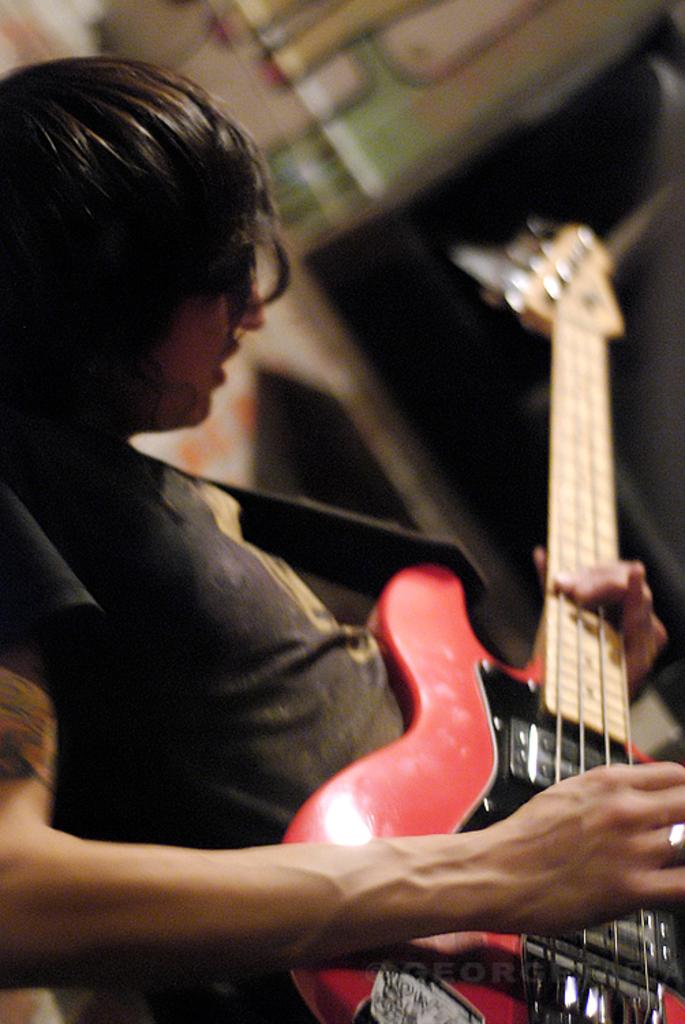What is the person in the image doing? The person is playing the guitar. What object is the person holding while playing? The person is holding a guitar. What is the person's focus while playing the guitar? The person is looking at the guitar. Can you describe the background of the image? The backdrop of the image is blurred. Is there a girl playing the guitar with a clam on the border of the image? There is no girl or clam present in the image, and there is no mention of a border. 